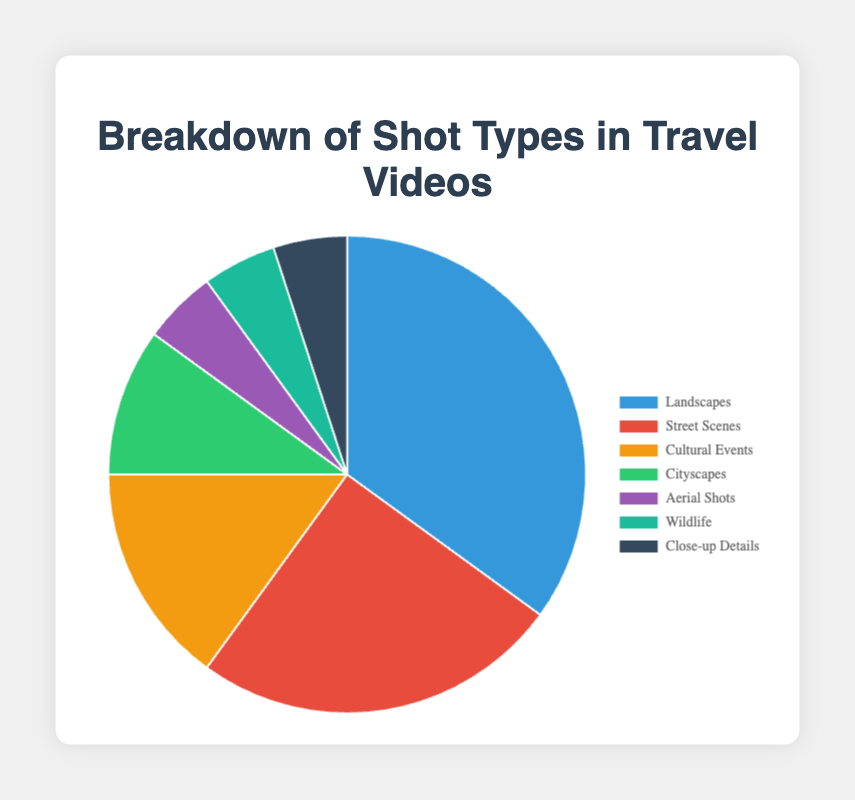What is the most frequently used shot type in travel videos? The largest segment in the pie chart represents the most frequently used shot type. "Landscapes" has the highest percentage at 35%.
Answer: Landscapes Which two shot types have the same percentage of use? The pie chart shows identical segments for "Aerial Shots," "Wildlife," and "Close-up Details," each taking up 5% of the pie. Therefore, any two of these categories have the same percentage.
Answer: Aerial Shots and Wildlife (or Close-up Details) How many more percentage points are "Street Scenes" compared to "Cityscapes"? "Street Scenes" make up 25% of the chart while "Cityscapes" make up 10%. Subtracting 10% from 25% gives a difference of 15 percentage points.
Answer: 15 percentage points What is the total percentage of all shot types except for "Landscapes" and "Street Scenes"? Adding the percentages of "Cultural Events" (15%), "Cityscapes" (10%), "Aerial Shots" (5%), "Wildlife" (5%), and "Close-up Details" (5%) gives a total of 40%.
Answer: 40% What shot types make up a quarter of the total pie chart? "Street Scenes" alone account for 25% of the total chart, which is one quarter.
Answer: Street Scenes Which shot type has a percentage equal to three times that of "Aerial Shots"? "Aerial Shots" account for 5%, three times this percentage is 15%, which corresponds to "Cultural Events".
Answer: Cultural Events What is the ratio of "Landscapes" to "Close-up Details" in terms of percentage? "Landscapes" make up 35%, and "Close-up Details" make up 5%. The ratio is 35:5, which simplifies to 7:1.
Answer: 7:1 If the "Landscapes" segment was divided in half, would any other segment be larger than each half? Dividing 35% (Landscapes) by 2 gives 17.5%. Since 17.5% is larger than any other single percentage value in the chart, no other segment would be larger than each half.
Answer: No How does the combined percentage of "Cultural Events" and "Cityscapes" compare to the percentage of "Street Scenes"? Adding "Cultural Events" (15%) and "Cityscapes" (10%) totals 25%, which is equal to the percentage of "Street Scenes."
Answer: Equal What is the visual color associated with "Wildlife"? In the given chart, "Wildlife" is represented with a specific color. By visually inspecting the pie chart, "Wildlife" is depicted in a greenish hue.
Answer: Green 